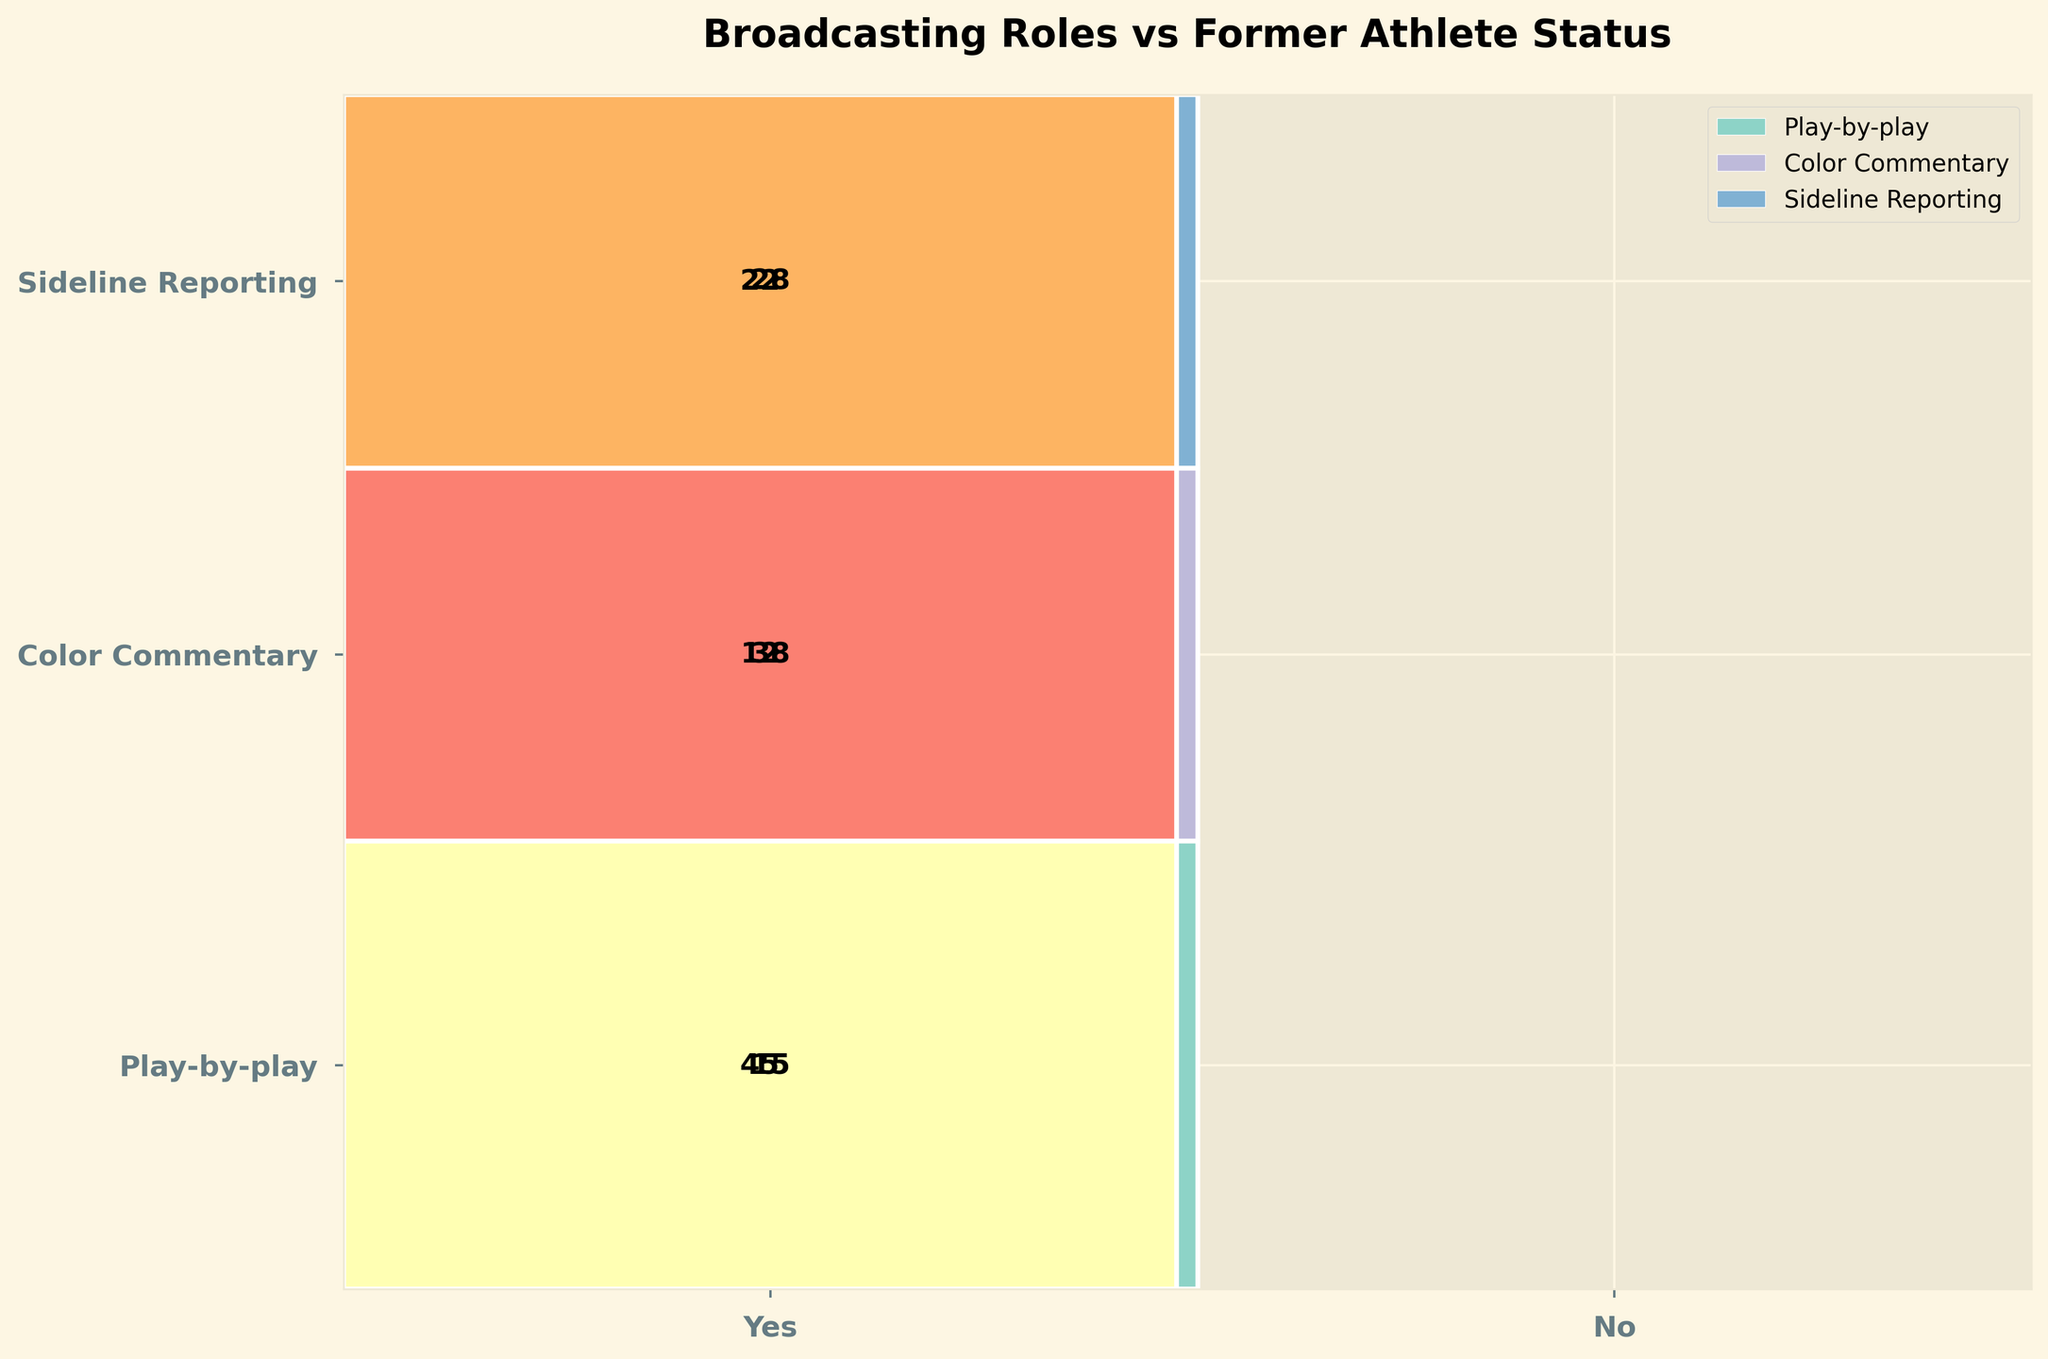Which broadcasting role has the highest number of former athletes? To determine this, examine which section dedicated to former athletes is the largest. The section "Color Commentary" for former athletes is clearly the largest.
Answer: Color Commentary What is the total number of individuals in the "Play-by-play" role? Adding both former athletes and non-athletes in the "Play-by-play" role, the sums are 12 (former athletes) + 38 (non-athletes) = 50.
Answer: 50 Which category has the smallest number of individuals: Former Athletes in "Sideline Reporting" or Non-Athletes in "Color Commentary"? By examining the figure, we can compare the counts. "Former Athletes in Sideline Reporting" is 22, and "Non-Athletes in Color Commentary" is 15.
Answer: Non-Athletes in Color Commentary Is the proportion of former athletes higher in "Color Commentary" or in "Sideline Reporting"? The total number of individuals in each role can be calculated, followed by the proportion of former athletes. The total for "Color Commentary" is 60, with 45 former athletes (45/60 = 0.75). The total for "Sideline Reporting" is 50, with 22 former athletes (22/50 = 0.44).
Answer: Color Commentary Among the non-athletes, which broadcasting role is the least frequent? By checking the numbers in the non-athletes' category, the counts are 38 for "Play-by-play", 15 for "Color Commentary", and 28 for "Sideline Reporting". The smallest number is for "Color Commentary".
Answer: Color Commentary How many more former athletes are there in "Color Commentary" compared to "Play-by-play"? Subtract the number of former athletes in "Play-by-play" from those in "Color Commentary": 45 (Color Commentary) - 12 (Play-by-play) = 33.
Answer: 33 What is the combined total number of former athletes in all roles? Sum all former athletes across different roles: 12 (Play-by-play) + 45 (Color Commentary) + 22 (Sideline Reporting) = 79.
Answer: 79 Compared to "Play-by-play", how does the number of former athletes in "Sideline Reporting" differ? Subtract the number of former athletes in "Play-by-play" from those in "Sideline Reporting": 22 (Sideline) - 12 (Play-by-play) = 10.
Answer: 10 